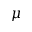Convert formula to latex. <formula><loc_0><loc_0><loc_500><loc_500>\mu</formula> 